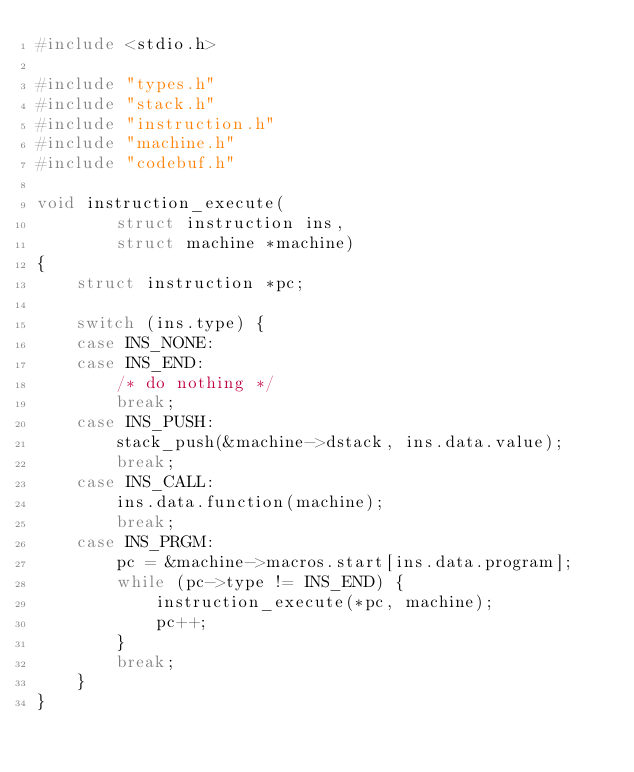<code> <loc_0><loc_0><loc_500><loc_500><_C_>#include <stdio.h>

#include "types.h"
#include "stack.h"
#include "instruction.h"
#include "machine.h"
#include "codebuf.h"

void instruction_execute(
		struct instruction ins,
		struct machine *machine)
{
	struct instruction *pc;

	switch (ins.type) {
	case INS_NONE:
	case INS_END:
		/* do nothing */
		break;
	case INS_PUSH:
		stack_push(&machine->dstack, ins.data.value);
		break;
	case INS_CALL:
		ins.data.function(machine);
		break;
	case INS_PRGM:
		pc = &machine->macros.start[ins.data.program];
		while (pc->type != INS_END) {
			instruction_execute(*pc, machine);
			pc++;
		}
		break;
	}
}
</code> 